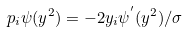<formula> <loc_0><loc_0><loc_500><loc_500>\ p _ { i } \psi ( y ^ { 2 } ) = - 2 y _ { i } \psi ^ { ^ { \prime } } ( y ^ { 2 } ) / \sigma</formula> 